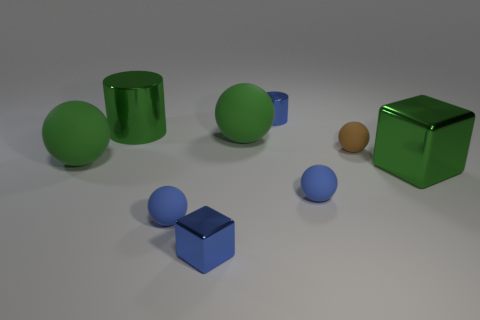Is the large cylinder the same color as the big shiny cube?
Offer a terse response. Yes. How big is the brown matte thing?
Provide a succinct answer. Small. The brown thing behind the big green metal object that is in front of the green rubber object that is left of the green cylinder is made of what material?
Your answer should be compact. Rubber. There is another cube that is the same material as the tiny blue block; what is its color?
Offer a very short reply. Green. There is a large metallic cube right of the metallic thing that is on the left side of the blue cube; how many tiny rubber things are behind it?
Provide a short and direct response. 1. How many objects are blue metallic objects that are to the right of the blue metallic cube or brown rubber things?
Keep it short and to the point. 2. Is the color of the big cylinder that is to the left of the tiny block the same as the large metal cube?
Your answer should be very brief. Yes. There is a big metallic object that is on the left side of the small rubber ball behind the green shiny cube; what is its shape?
Provide a short and direct response. Cylinder. Are there fewer tiny blue cylinders to the right of the green metallic block than matte balls to the left of the blue metal cylinder?
Offer a terse response. Yes. How many things are either blue blocks that are in front of the brown matte sphere or big green shiny things that are in front of the tiny brown thing?
Keep it short and to the point. 2. 